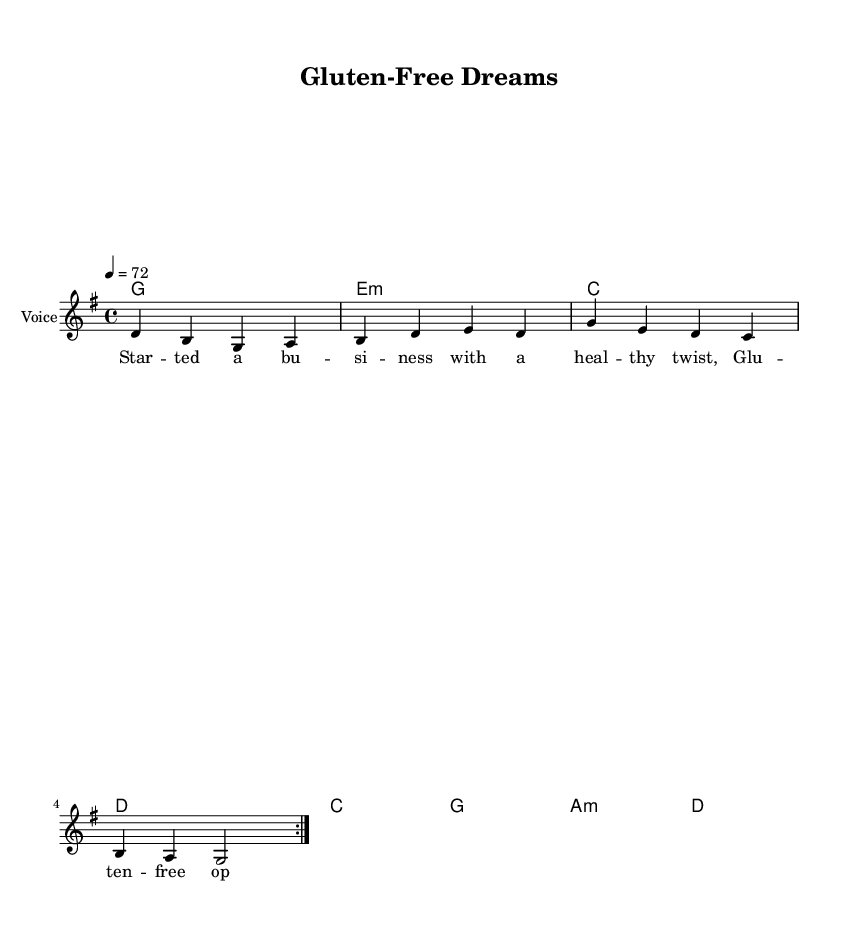What is the key signature of this music? The key signature is indicated at the beginning of the score, which shows one sharp on the staff, corresponding to the key of G major.
Answer: G major What is the time signature of this music? The time signature is located at the beginning of the piece. It displays a "4/4," indicating four beats per measure.
Answer: 4/4 What is the tempo marking for this music? The tempo marking appears at the beginning, where it states "4 = 72," meaning there are 72 quarter note beats per minute.
Answer: 72 How many measures are repeated in the melody? The score indicates a repeat section with the phrase "repeat volta 2", which signifies that there are two measures being repeated.
Answer: 2 measures What is the first chord in the harmonies? The first chord is written at the beginning of the harmony section, which is a G major chord.
Answer: G What lyrical theme is explored in this music? Analyzing the provided lyrics, the theme revolves around starting a business with a focus on healthy gluten-free options, emphasizing entrepreneurial pursuits.
Answer: Healthy twist What type of musical genre does this piece belong to? The style and instrumentation of the music, along with the lyrical content about entrepreneurial challenges, clearly indicate that this falls under the country rock genre.
Answer: Country Rock 